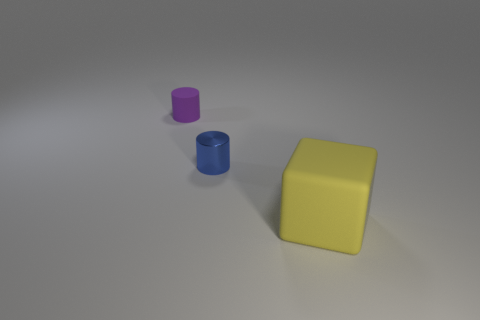Add 2 tiny rubber cylinders. How many objects exist? 5 Subtract all blocks. How many objects are left? 2 Add 2 small metal things. How many small metal things exist? 3 Subtract 0 yellow spheres. How many objects are left? 3 Subtract all metallic cylinders. Subtract all matte objects. How many objects are left? 0 Add 1 big yellow objects. How many big yellow objects are left? 2 